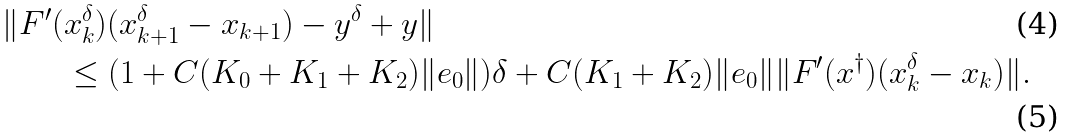Convert formula to latex. <formula><loc_0><loc_0><loc_500><loc_500>\| F ^ { \prime } ( & x _ { k } ^ { \delta } ) ( x _ { k + 1 } ^ { \delta } - x _ { k + 1 } ) - y ^ { \delta } + y \| \\ & \leq ( 1 + C ( K _ { 0 } + K _ { 1 } + K _ { 2 } ) \| e _ { 0 } \| ) \delta + C ( K _ { 1 } + K _ { 2 } ) \| e _ { 0 } \| \| F ^ { \prime } ( x ^ { \dag } ) ( x _ { k } ^ { \delta } - x _ { k } ) \| .</formula> 